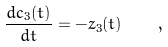Convert formula to latex. <formula><loc_0><loc_0><loc_500><loc_500>\frac { d c _ { 3 } ( t ) } { d t } = - z _ { 3 } ( t ) \quad ,</formula> 